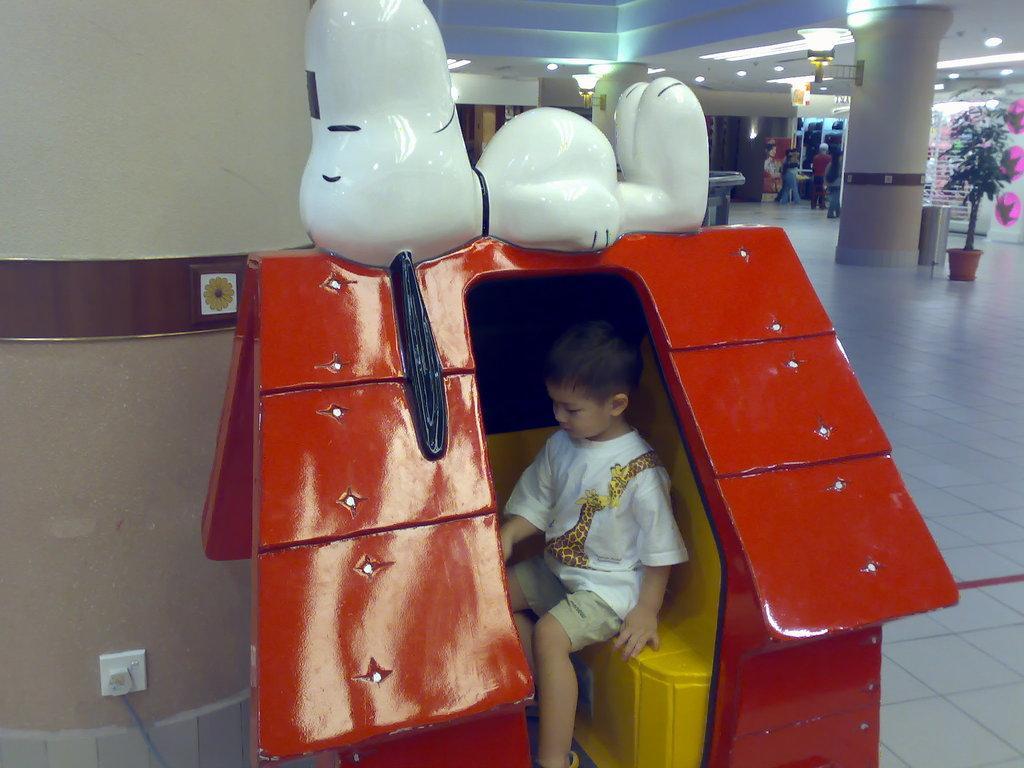Could you give a brief overview of what you see in this image? In this picture, we see the boy in the white T-shirt is sitting on the yellow colored stool like structure. It looks like a hut and it is in red color. On top of it, we see the toy in white color. Behind that, we see a pillar and the plug. On the right side, we see the plant pot, garbage bin and the pillar. We see the people are standing. In the background, we see the wall. At the top, we see the ceiling of the room. 